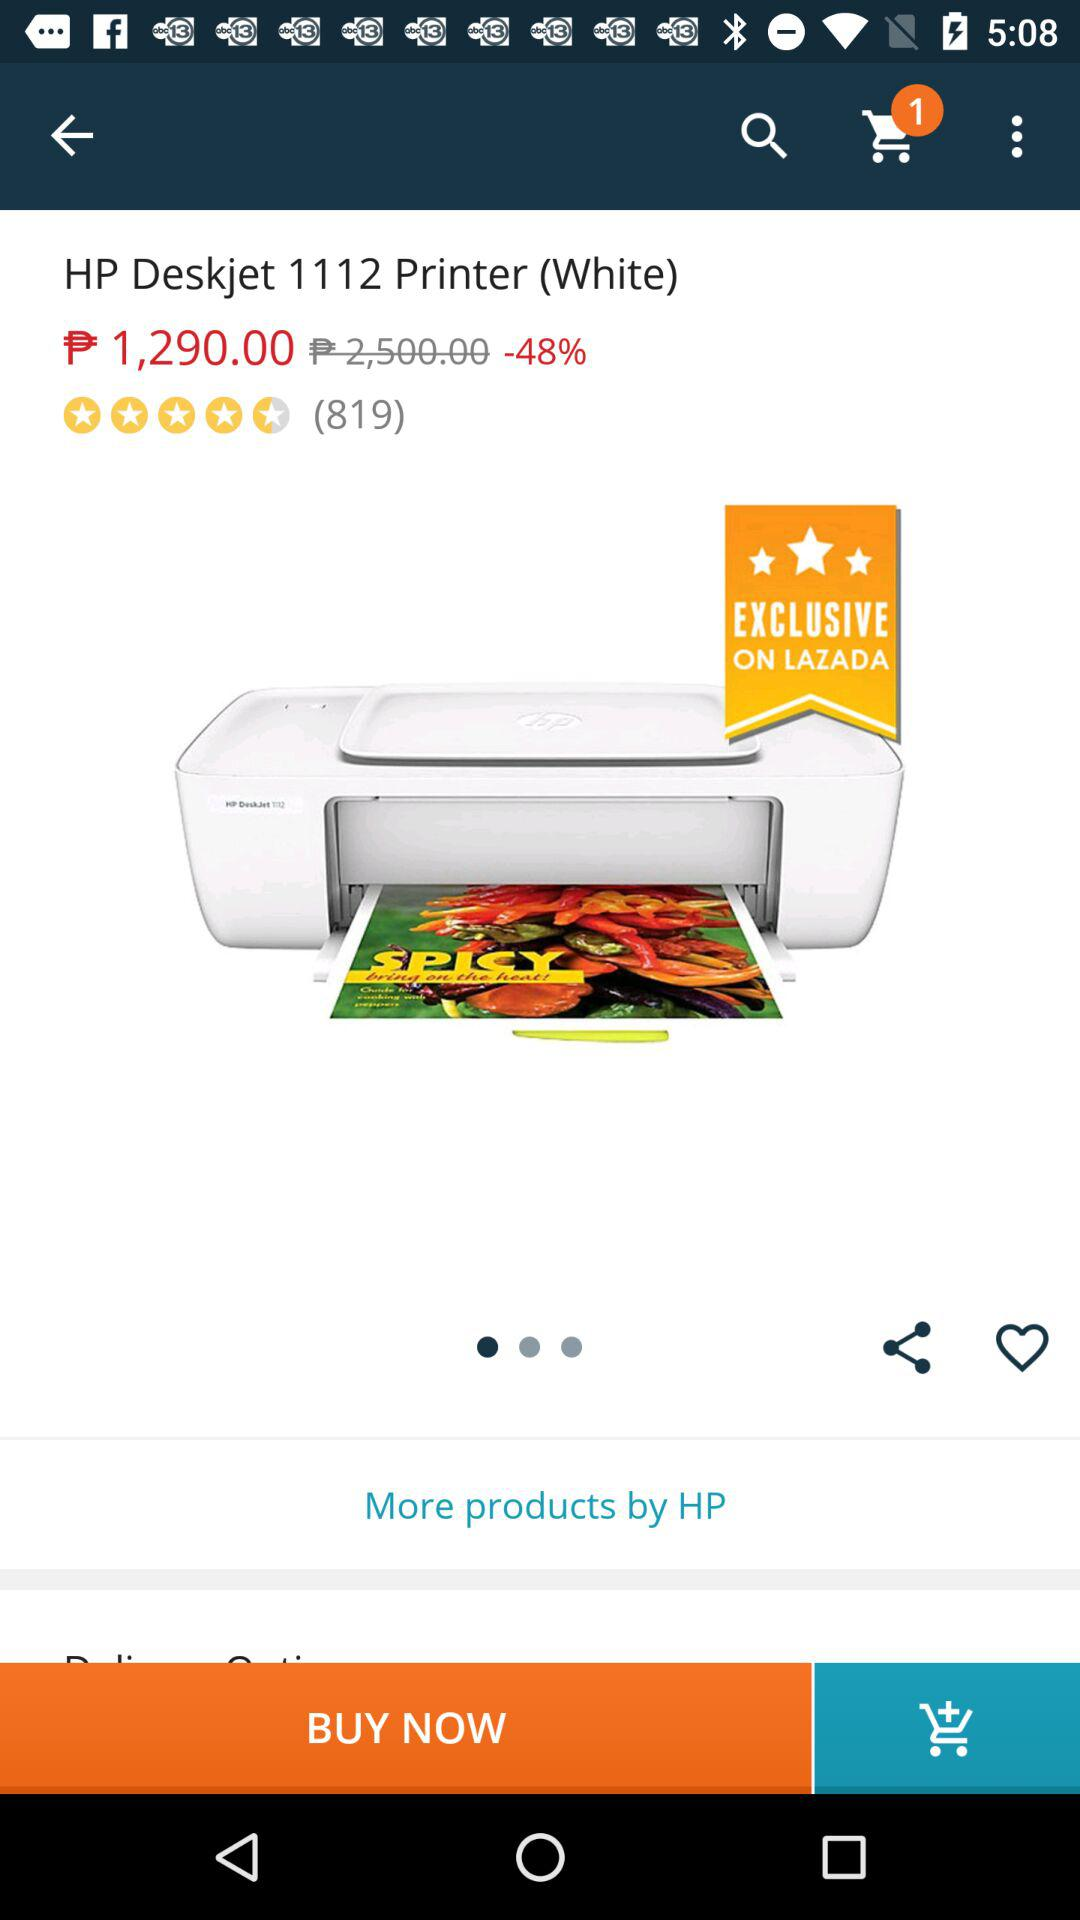How many items are in the shopping cart? There is 1 item. 